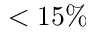Convert formula to latex. <formula><loc_0><loc_0><loc_500><loc_500>< 1 5 \%</formula> 